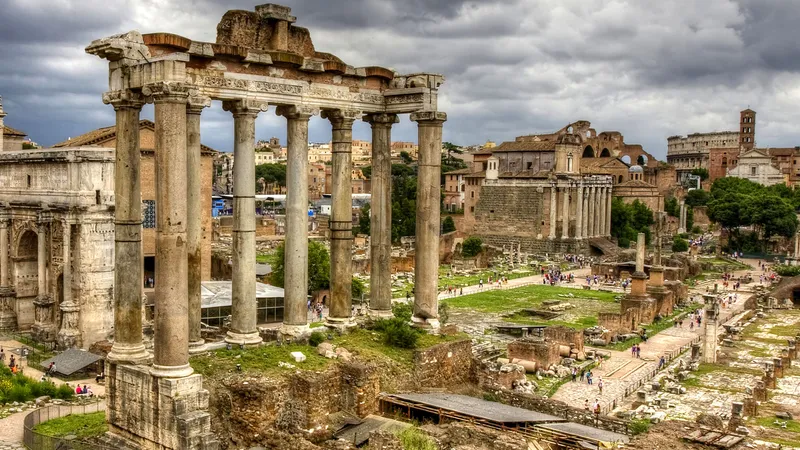What's happening in the scene? The image provides a breathtaking overview of the Roman Forum in Rome, Italy, showcasing a variety of ancient ruins that date back to the Roman Republic. The high-angle view captures the extensive layout of the Forum, including several iconic structures such as the remains of temples, government buildings, and marketplaces that were central to Roman public life. The ruins, characterized by crumbling columns and arches, offer a silent narrative of the historical events that took place here, from triumphal processions to public speeches. The overcast sky adds a dramatic nuance to the scene, emphasizing the age and historical weight of the Forum. This image not only captures the physical remnants of the past but also invokes the bustling atmosphere that once pervaded this pivotal civic center. 